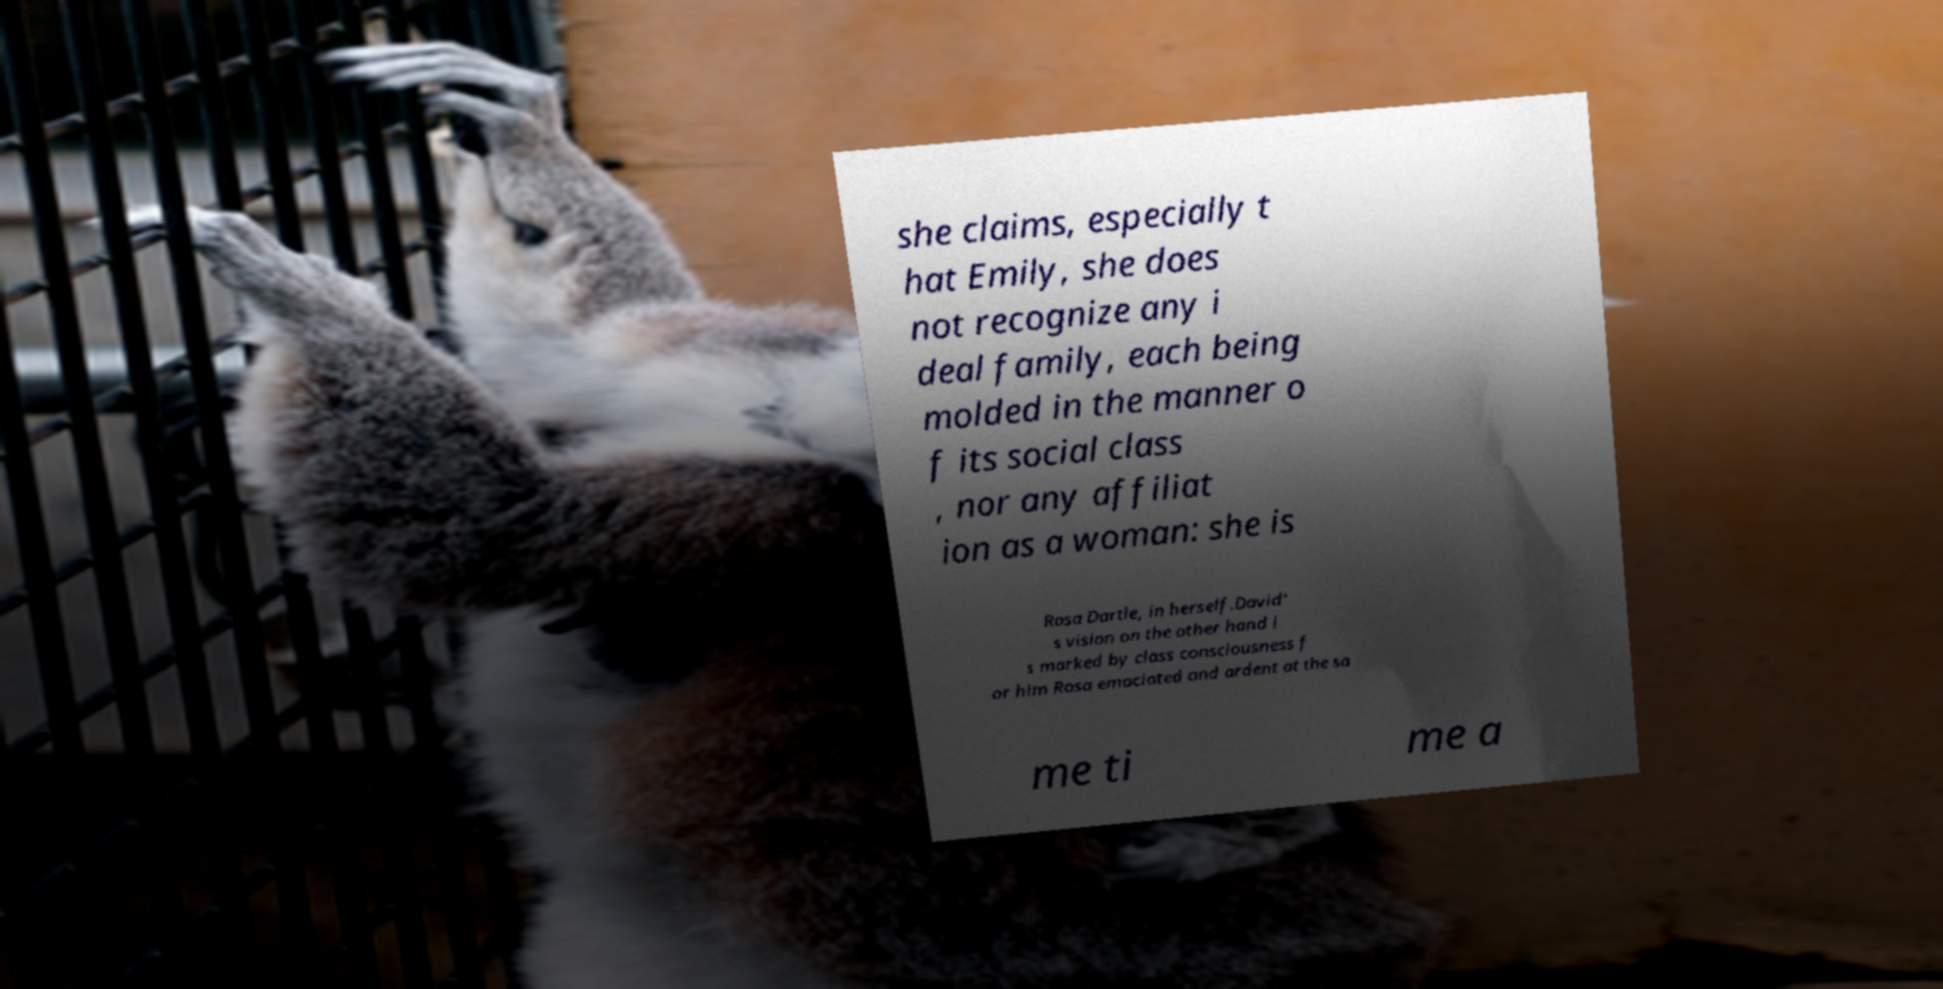Please identify and transcribe the text found in this image. she claims, especially t hat Emily, she does not recognize any i deal family, each being molded in the manner o f its social class , nor any affiliat ion as a woman: she is Rosa Dartle, in herself.David' s vision on the other hand i s marked by class consciousness f or him Rosa emaciated and ardent at the sa me ti me a 